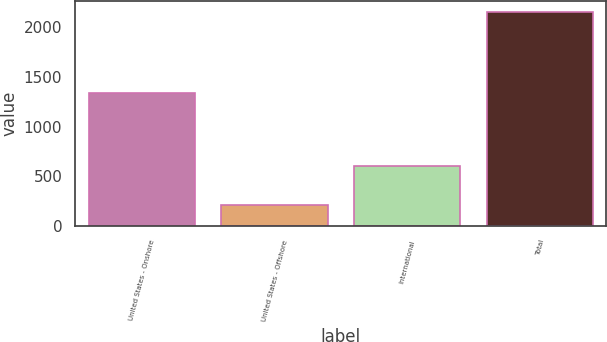Convert chart. <chart><loc_0><loc_0><loc_500><loc_500><bar_chart><fcel>United States - Onshore<fcel>United States - Offshore<fcel>International<fcel>Total<nl><fcel>1341.5<fcel>210.5<fcel>604<fcel>2156<nl></chart> 